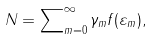<formula> <loc_0><loc_0><loc_500><loc_500>N = \sum \nolimits _ { m = 0 } ^ { \infty } \gamma _ { m } f ( \varepsilon _ { m } ) ,</formula> 